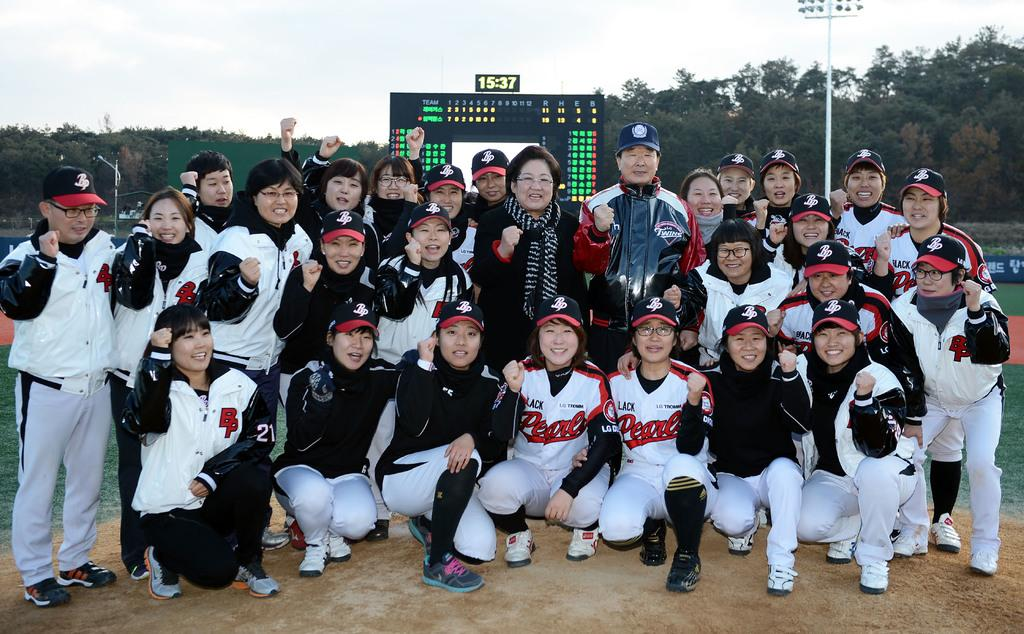How many people are in the image? There is a group of people in the image, but the exact number cannot be determined from the provided facts. What are the people in the image doing? The people are posing for a camera in the image. What type of natural environment is visible in the image? There is grass and trees in the background of the image, indicating a natural setting. What other objects can be seen in the background of the image? There are poles and a screen in the background of the image. What is visible in the sky in the image? The sky is visible in the background of the image. What type of table is being used to adjust the camera angle in the image? There is no table or camera angle adjustment visible in the image. What line can be seen connecting the trees in the background of the image? There is no line connecting the trees in the background of the image. 